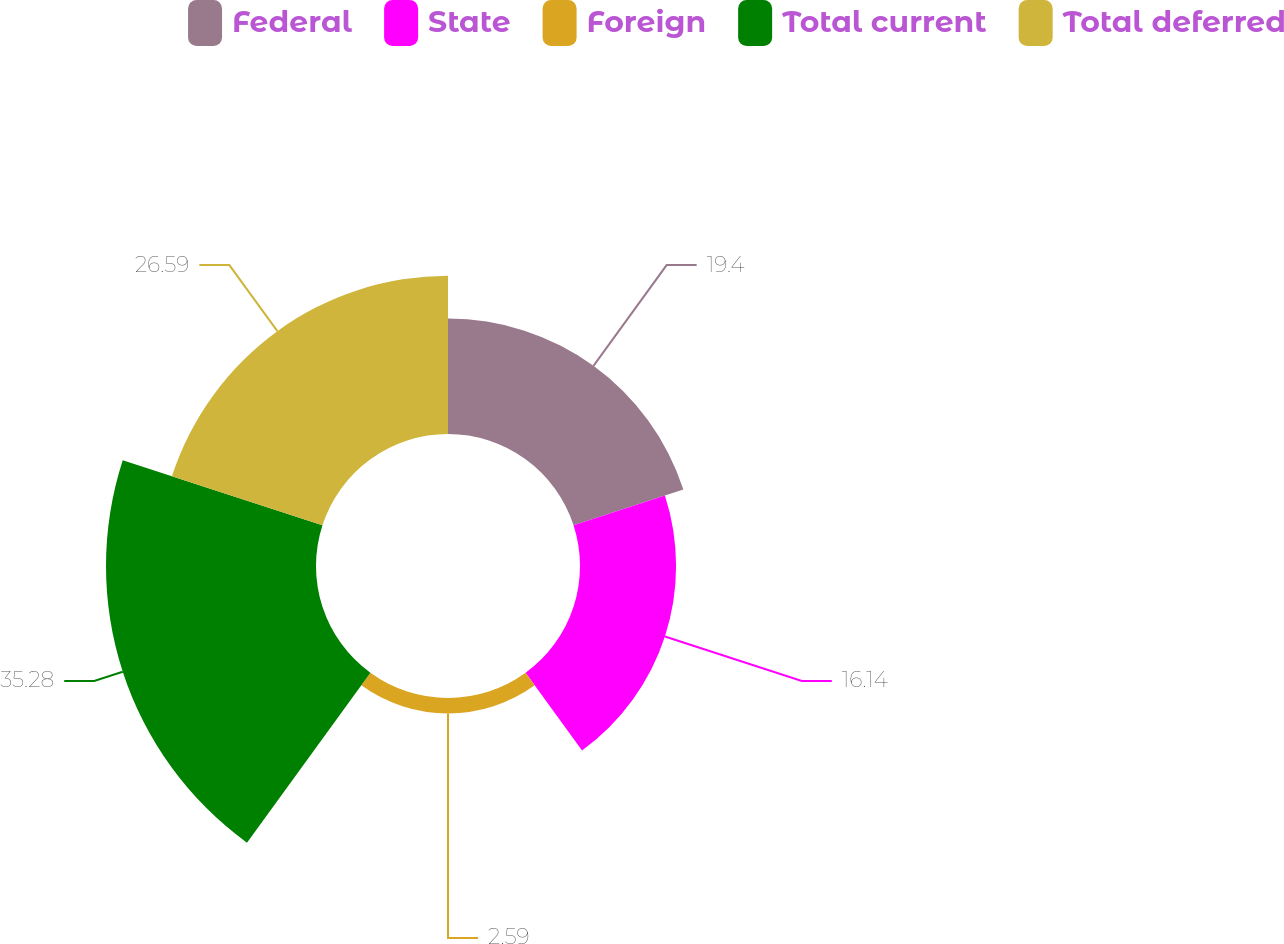Convert chart to OTSL. <chart><loc_0><loc_0><loc_500><loc_500><pie_chart><fcel>Federal<fcel>State<fcel>Foreign<fcel>Total current<fcel>Total deferred<nl><fcel>19.4%<fcel>16.14%<fcel>2.59%<fcel>35.28%<fcel>26.59%<nl></chart> 